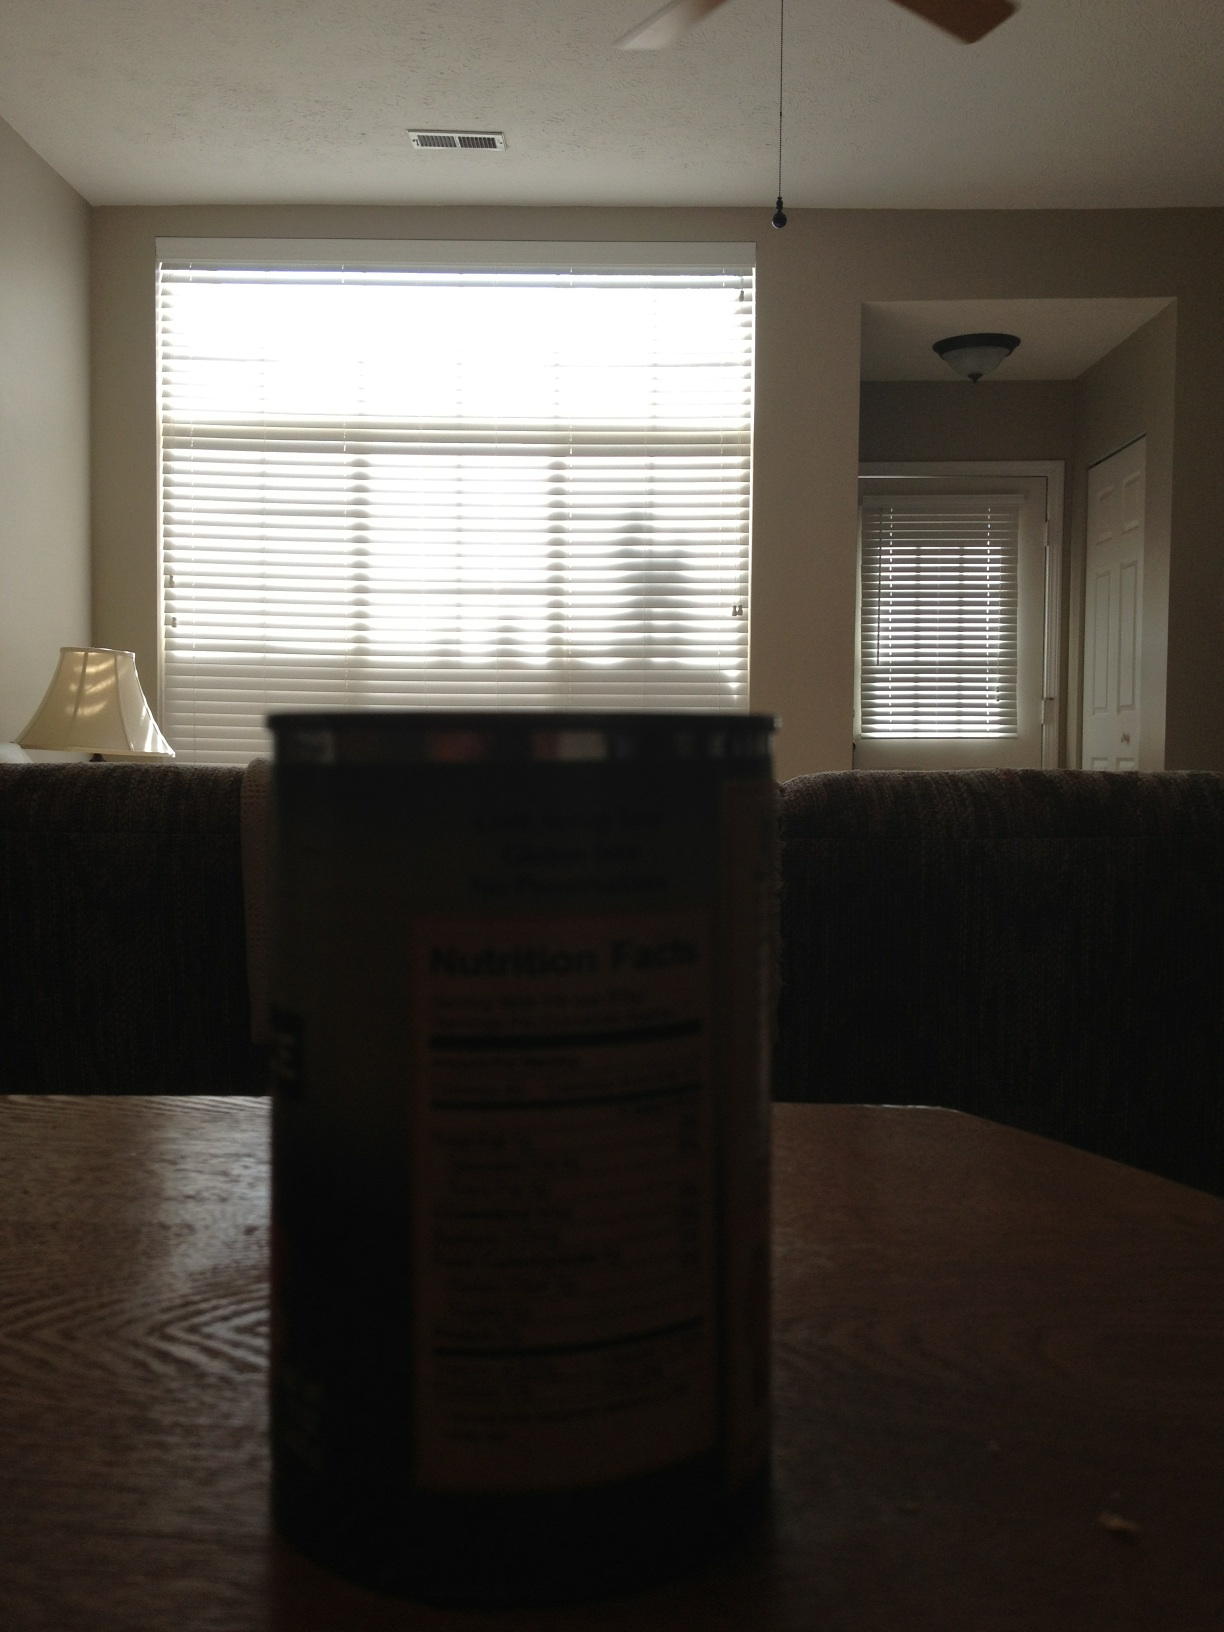How could you describe the texture and color of the can in the image? The can in the foreground has a metallic sheen, reflecting hints of the ambient light. The label appears to be dark, but details are hard to discern due to the lighting. 